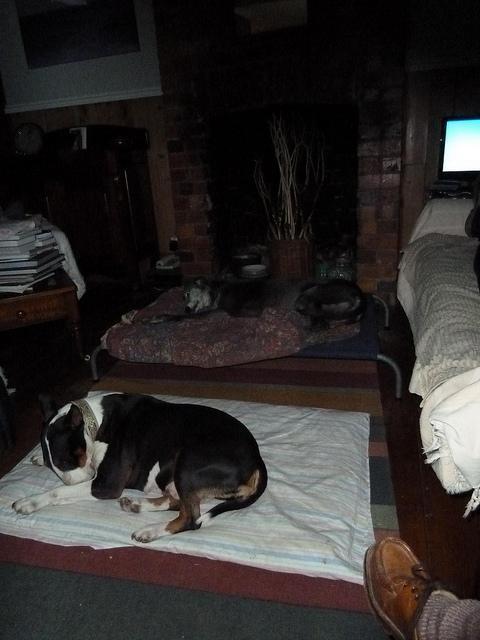What can be built along the back wall?
Choose the right answer and clarify with the format: 'Answer: answer
Rationale: rationale.'
Options: Snow man, gingerbread, clothing, fire. Answer: fire.
Rationale: The area in the back is connected to chimney, and is meant to burn things for warmth. 